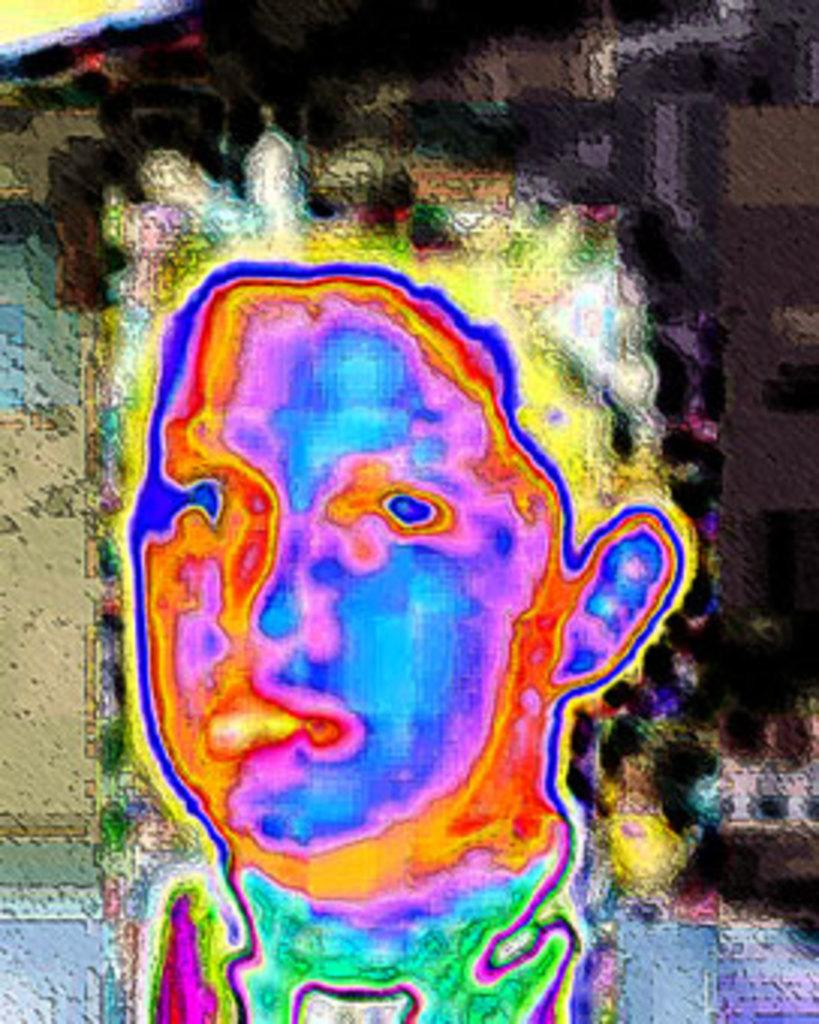What editing has been done to the image? The image has been edited, but the specific editing details are not mentioned in the facts. What colors are present in the image? The image contains blue, green, red, pink, orange, and yellow colors. What is the color of the background in the image? The background of the image is black in color. What type of apparel is being worn by the rose in the image? There is no rose or apparel present in the image. What connection can be made between the colors in the image and the editing process? The facts do not provide any information about the connection between the colors and the editing process. 